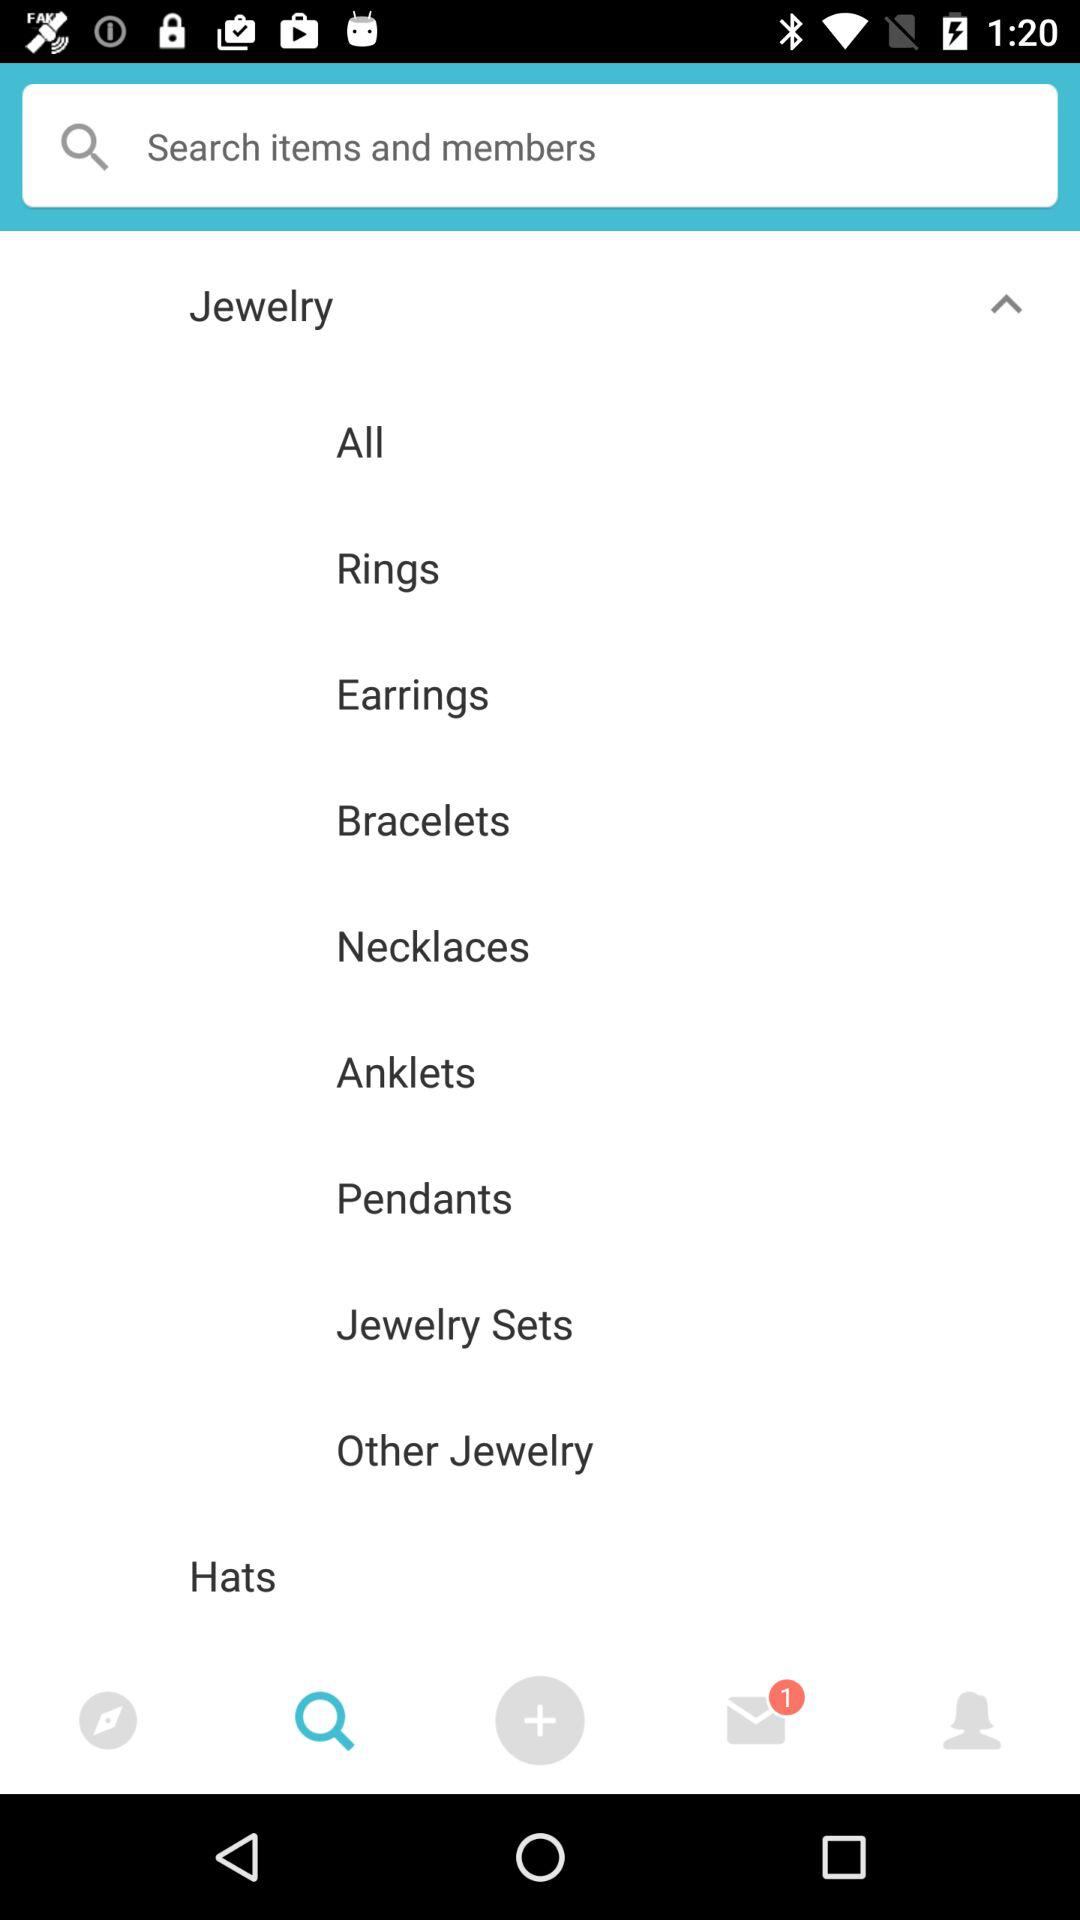What is the number of unread messages? The number of unread messages is 1. 